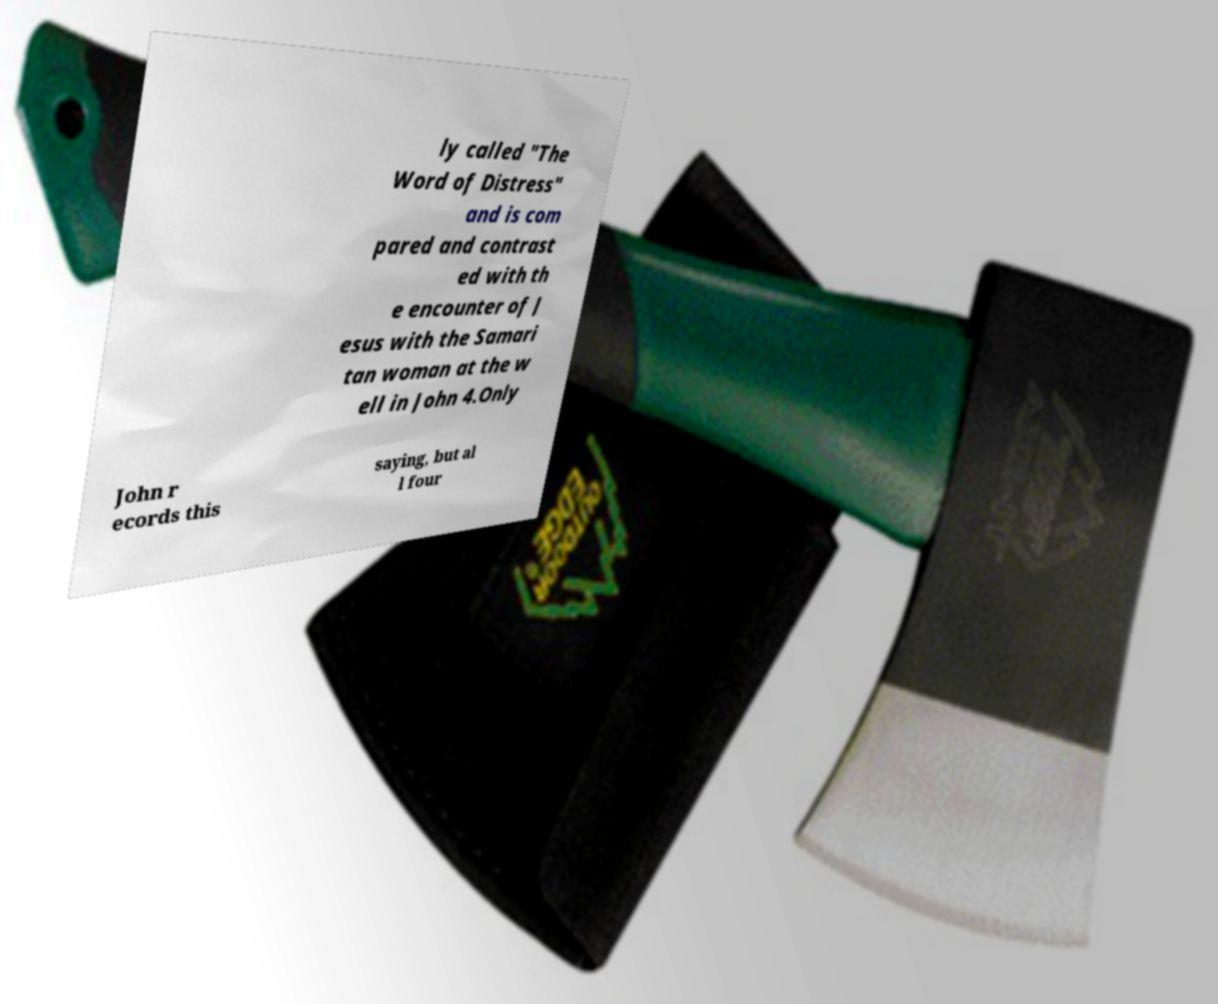Could you extract and type out the text from this image? ly called "The Word of Distress" and is com pared and contrast ed with th e encounter of J esus with the Samari tan woman at the w ell in John 4.Only John r ecords this saying, but al l four 